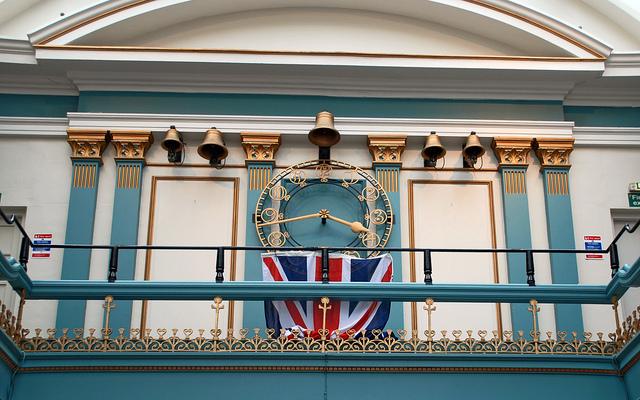What time is displayed on the clock?
Keep it brief. 3:43. What country is this?
Answer briefly. England. Is this an official building?
Be succinct. Yes. 